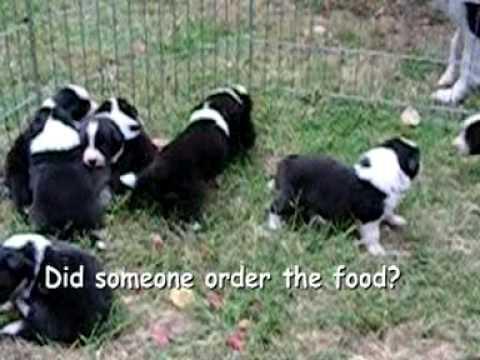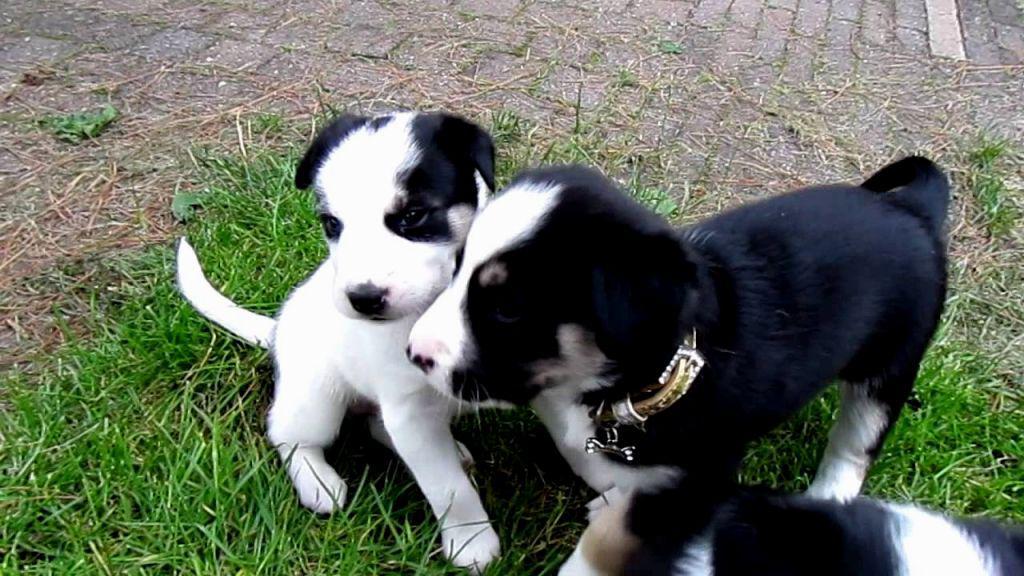The first image is the image on the left, the second image is the image on the right. Considering the images on both sides, is "An image contains a single black-and-white dog, which is sitting up and looking intently at something." valid? Answer yes or no. No. 